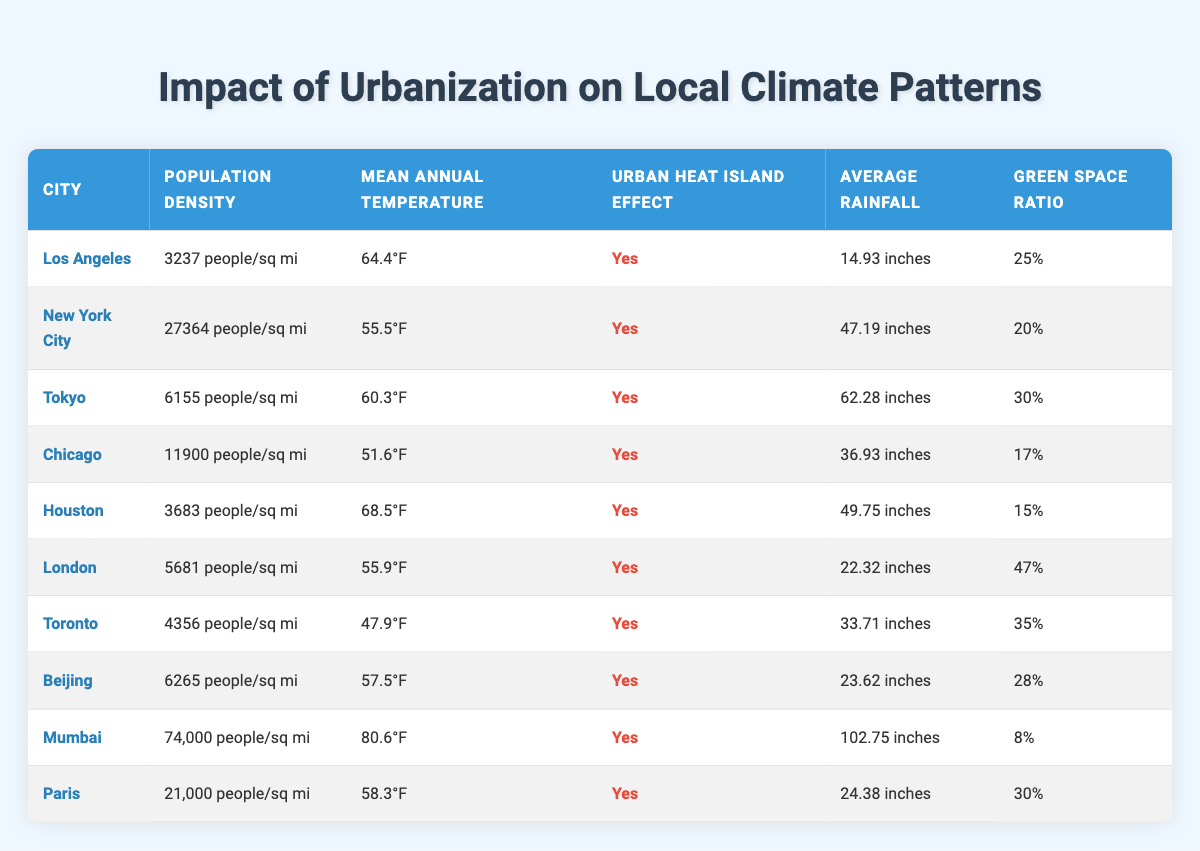What is the population density of Mumbai? The table lists the city of Mumbai with its population density specified as 74,000 people/sq mi.
Answer: 74,000 people/sq mi Which city has the highest mean annual temperature? By comparing the mean annual temperatures in the table, Mumbai has the highest temperature at 80.6°F, higher than other cities listed.
Answer: Mumbai How many cities have a green space ratio of 30% or more? In the table, there are three cities (Tokyo, Toronto, and London) with a green space ratio of 30% or more.
Answer: 3 What is the average population density of the cities listed? First, we calculate the population densities from the table: 3237, 27364, 6155, 11900, 3683, 5681, 4356, 6265, 74000, and 21000. Summing them gives 182,641. There are 10 cities, so the average is 182641/10 = 18264.1.
Answer: 18264.1 people/sq mi Does London have an urban heat island effect? The table indicates "Yes" under the urban heat island effect column for London, confirming that it does experience this effect.
Answer: Yes Which city has the lowest average rainfall, and what is it? Observing the average rainfall column, Los Angeles has the lowest average rainfall at 14.93 inches, which is confirmed by comparing all cities.
Answer: 14.93 inches What is the difference in mean annual temperature between Los Angeles and Chicago? Los Angeles has a mean annual temperature of 64.4°F and Chicago has 51.6°F. The difference is calculated as 64.4 - 51.6 = 12.8°F.
Answer: 12.8°F Is there a correlation between population density and the presence of urban heat island effect among these cities? Reviewing the table, all cities listed have "Yes" under the urban heat island effect, indicating that all urbanized areas studied experience this phenomenon, suggesting a possible correlation.
Answer: Yes What is the mean green space ratio among the cities listed? First, we list the green space ratios: 25%, 20%, 30%, 17%, 15%, 47%, 35%, 28%, 8%, and 30%. Summing these yields  25+20+30+17+15+47+35+28+8+30 = 285. Dividing this sum by 10 gives an average of 28.5%.
Answer: 28.5% 